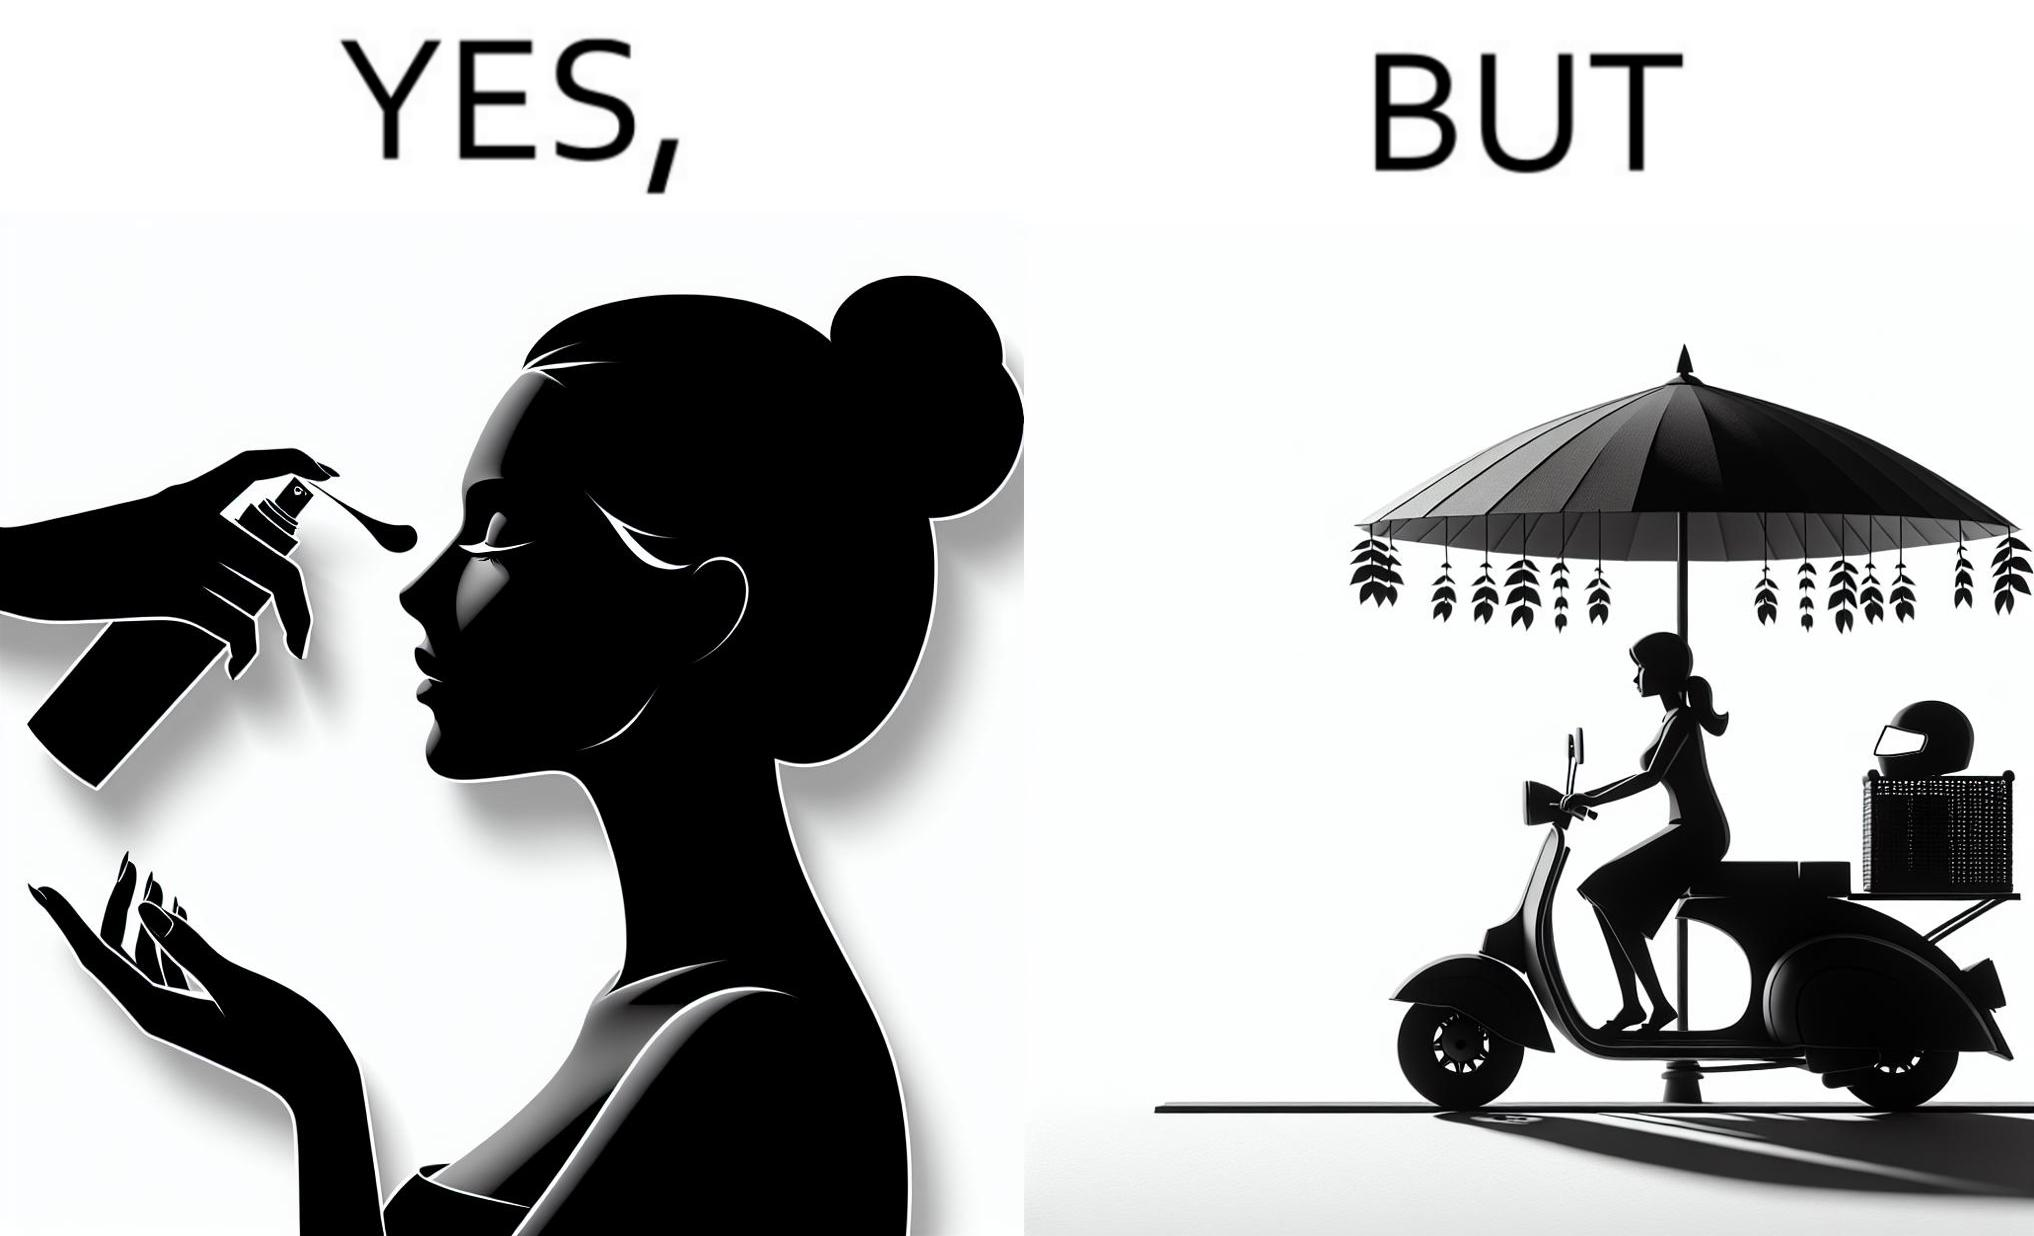Is there satirical content in this image? Yes, this image is satirical. 